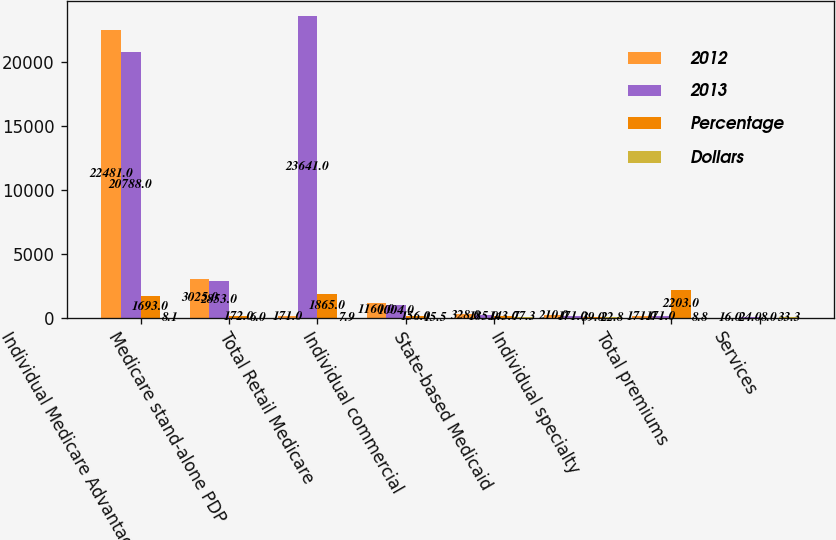Convert chart to OTSL. <chart><loc_0><loc_0><loc_500><loc_500><stacked_bar_chart><ecel><fcel>Individual Medicare Advantage<fcel>Medicare stand-alone PDP<fcel>Total Retail Medicare<fcel>Individual commercial<fcel>State-based Medicaid<fcel>Individual specialty<fcel>Total premiums<fcel>Services<nl><fcel>2012<fcel>22481<fcel>3025<fcel>171<fcel>1160<fcel>328<fcel>210<fcel>171<fcel>16<nl><fcel>2013<fcel>20788<fcel>2853<fcel>23641<fcel>1004<fcel>185<fcel>171<fcel>171<fcel>24<nl><fcel>Percentage<fcel>1693<fcel>172<fcel>1865<fcel>156<fcel>143<fcel>39<fcel>2203<fcel>8<nl><fcel>Dollars<fcel>8.1<fcel>6<fcel>7.9<fcel>15.5<fcel>77.3<fcel>22.8<fcel>8.8<fcel>33.3<nl></chart> 